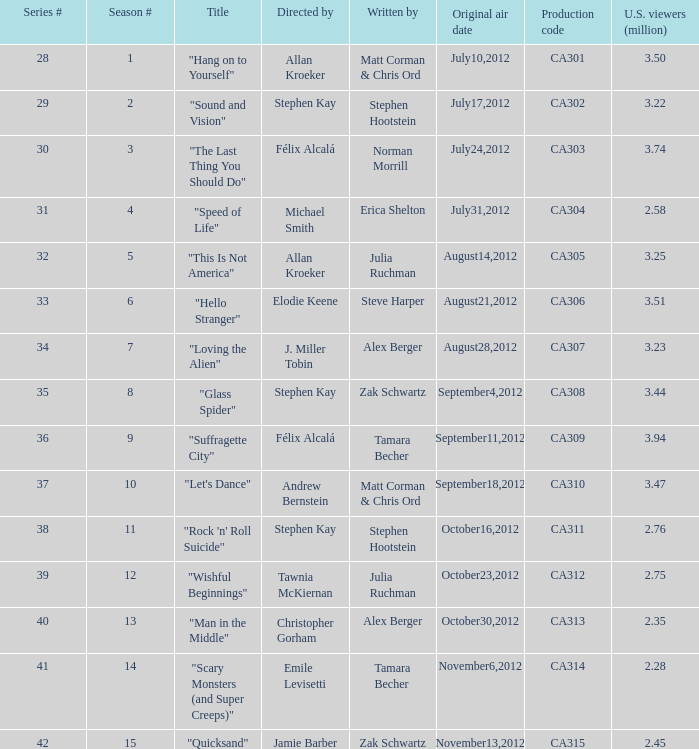Which episode had 2.75 million viewers in the U.S.? "Wishful Beginnings". 